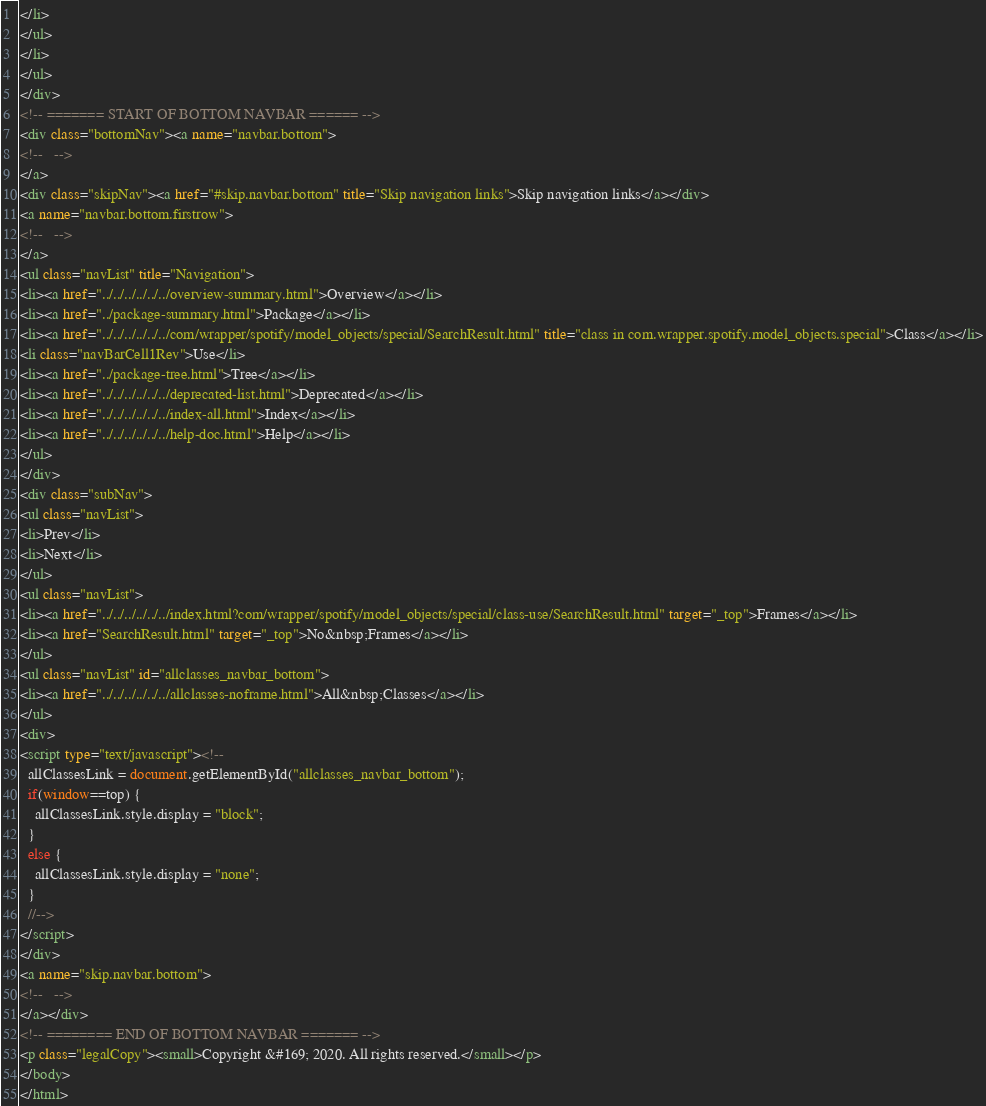Convert code to text. <code><loc_0><loc_0><loc_500><loc_500><_HTML_></li>
</ul>
</li>
</ul>
</div>
<!-- ======= START OF BOTTOM NAVBAR ====== -->
<div class="bottomNav"><a name="navbar.bottom">
<!--   -->
</a>
<div class="skipNav"><a href="#skip.navbar.bottom" title="Skip navigation links">Skip navigation links</a></div>
<a name="navbar.bottom.firstrow">
<!--   -->
</a>
<ul class="navList" title="Navigation">
<li><a href="../../../../../../overview-summary.html">Overview</a></li>
<li><a href="../package-summary.html">Package</a></li>
<li><a href="../../../../../../com/wrapper/spotify/model_objects/special/SearchResult.html" title="class in com.wrapper.spotify.model_objects.special">Class</a></li>
<li class="navBarCell1Rev">Use</li>
<li><a href="../package-tree.html">Tree</a></li>
<li><a href="../../../../../../deprecated-list.html">Deprecated</a></li>
<li><a href="../../../../../../index-all.html">Index</a></li>
<li><a href="../../../../../../help-doc.html">Help</a></li>
</ul>
</div>
<div class="subNav">
<ul class="navList">
<li>Prev</li>
<li>Next</li>
</ul>
<ul class="navList">
<li><a href="../../../../../../index.html?com/wrapper/spotify/model_objects/special/class-use/SearchResult.html" target="_top">Frames</a></li>
<li><a href="SearchResult.html" target="_top">No&nbsp;Frames</a></li>
</ul>
<ul class="navList" id="allclasses_navbar_bottom">
<li><a href="../../../../../../allclasses-noframe.html">All&nbsp;Classes</a></li>
</ul>
<div>
<script type="text/javascript"><!--
  allClassesLink = document.getElementById("allclasses_navbar_bottom");
  if(window==top) {
    allClassesLink.style.display = "block";
  }
  else {
    allClassesLink.style.display = "none";
  }
  //-->
</script>
</div>
<a name="skip.navbar.bottom">
<!--   -->
</a></div>
<!-- ======== END OF BOTTOM NAVBAR ======= -->
<p class="legalCopy"><small>Copyright &#169; 2020. All rights reserved.</small></p>
</body>
</html>
</code> 